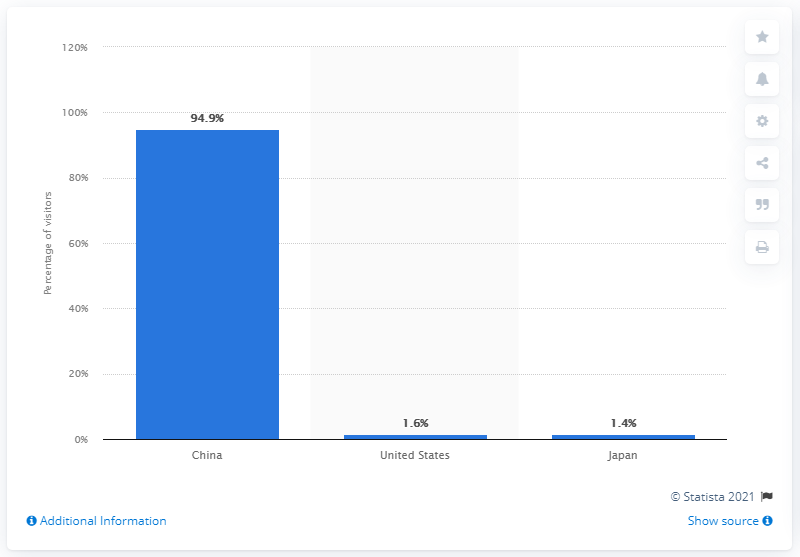Outline some significant characteristics in this image. According to the data, the vast majority of visitors to the website baidu.com came from China. Approximately 1.4% of the visitors to baidu.com came from Japan. 